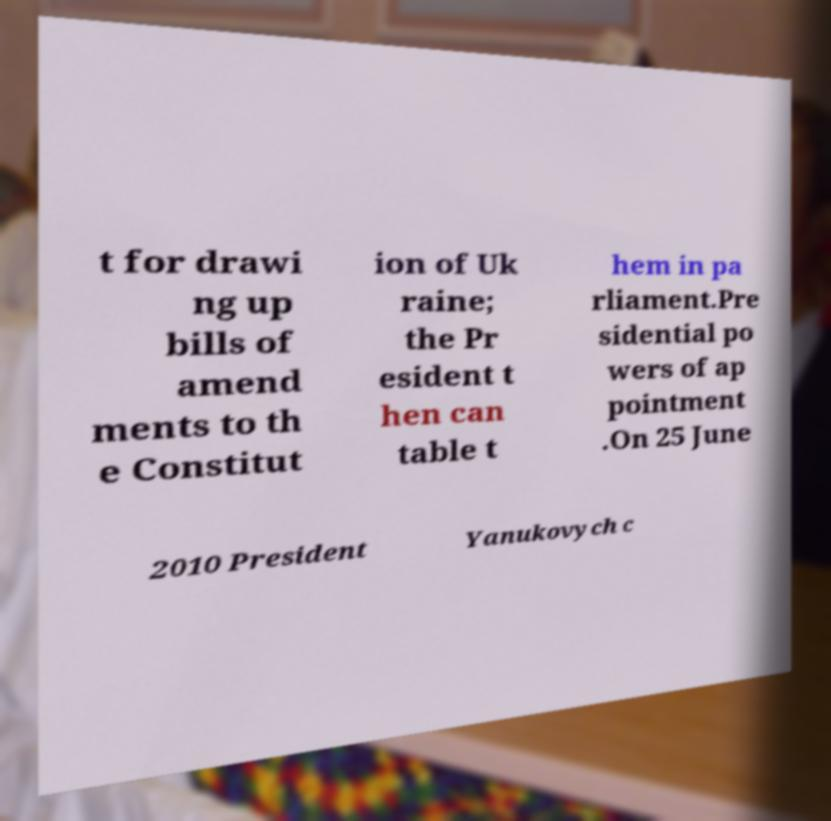Please read and relay the text visible in this image. What does it say? t for drawi ng up bills of amend ments to th e Constitut ion of Uk raine; the Pr esident t hen can table t hem in pa rliament.Pre sidential po wers of ap pointment .On 25 June 2010 President Yanukovych c 